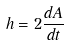<formula> <loc_0><loc_0><loc_500><loc_500>h = 2 \frac { d A } { d t }</formula> 